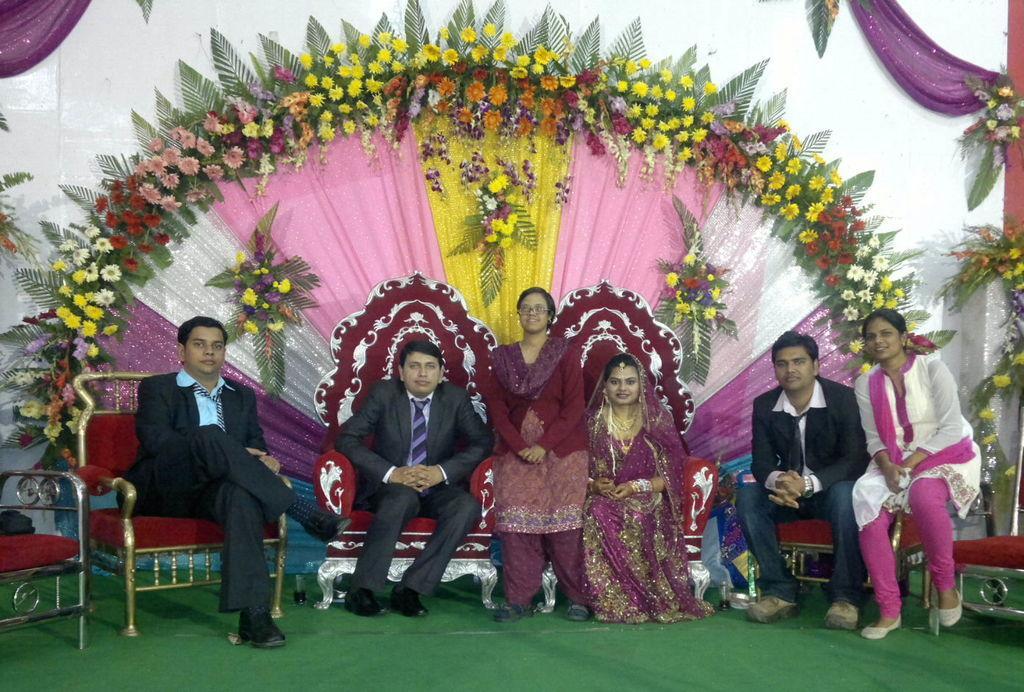In one or two sentences, can you explain what this image depicts? This image consists of seven persons. They are sitting on the dais. At the bottom, there is a green carpet. In the background, we can see many flowers and clothes. 